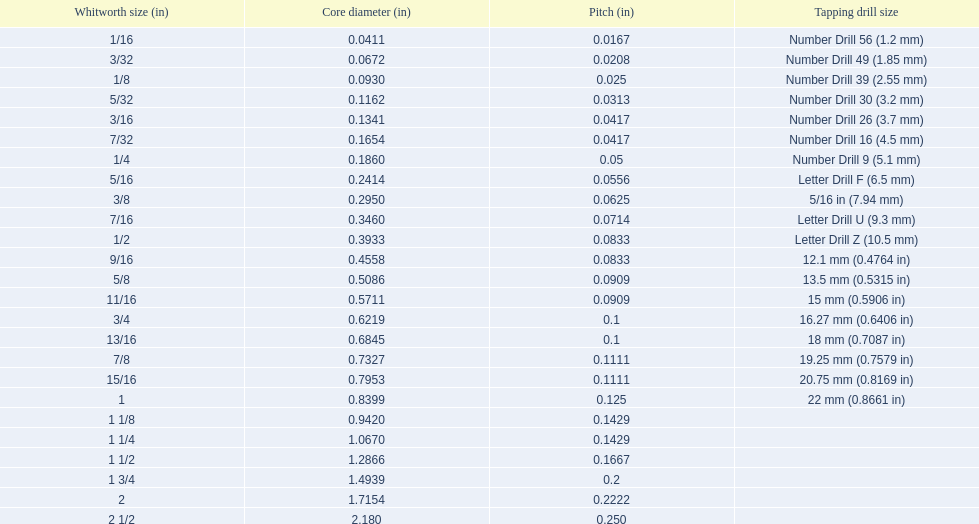What are all the whitworth sizes? 1/16, 3/32, 1/8, 5/32, 3/16, 7/32, 1/4, 5/16, 3/8, 7/16, 1/2, 9/16, 5/8, 11/16, 3/4, 13/16, 7/8, 15/16, 1, 1 1/8, 1 1/4, 1 1/2, 1 3/4, 2, 2 1/2. What are the threads per inch of these sizes? 60, 48, 40, 32, 24, 24, 20, 18, 16, 14, 12, 12, 11, 11, 10, 10, 9, 9, 8, 7, 7, 6, 5, 4.5, 4. Of these, which are 5? 5. What whitworth size has this threads per inch? 1 3/4. 